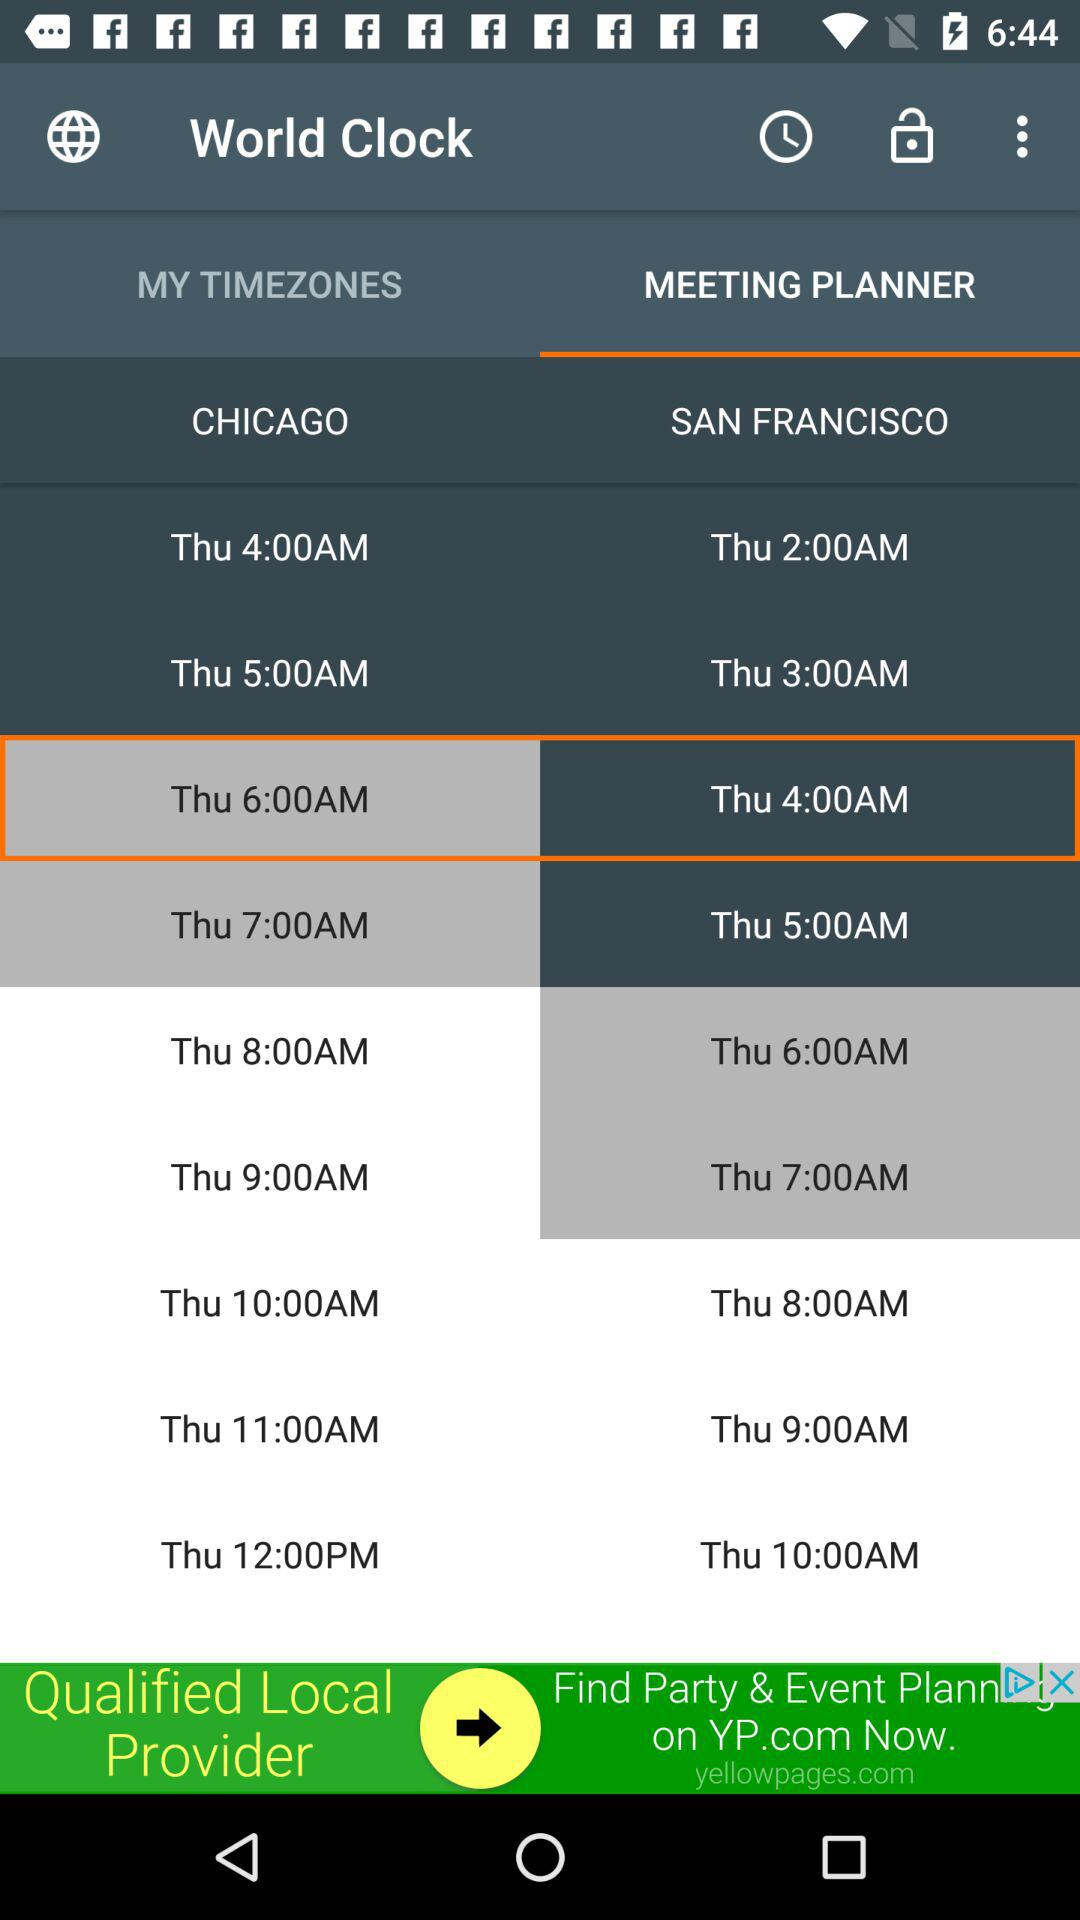Which tab is selected? The selected tab is Meeting Planner. 